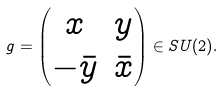Convert formula to latex. <formula><loc_0><loc_0><loc_500><loc_500>g = \begin{pmatrix} x & y \\ - \bar { y } & \bar { x } \end{pmatrix} \in S U ( 2 ) .</formula> 